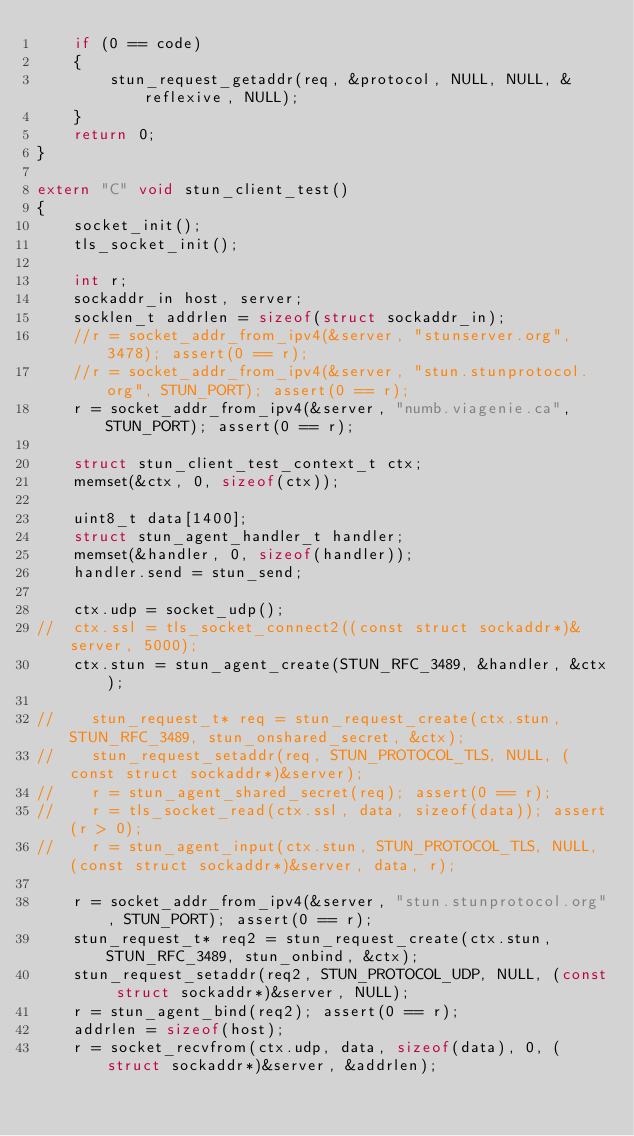Convert code to text. <code><loc_0><loc_0><loc_500><loc_500><_C++_>	if (0 == code)
	{
		stun_request_getaddr(req, &protocol, NULL, NULL, &reflexive, NULL);
	}
	return 0;
}

extern "C" void stun_client_test()
{
	socket_init();
	tls_socket_init();

	int r;
    sockaddr_in host, server;
	socklen_t addrlen = sizeof(struct sockaddr_in);
	//r = socket_addr_from_ipv4(&server, "stunserver.org", 3478); assert(0 == r);
	//r = socket_addr_from_ipv4(&server, "stun.stunprotocol.org", STUN_PORT); assert(0 == r);
	r = socket_addr_from_ipv4(&server, "numb.viagenie.ca", STUN_PORT); assert(0 == r);
    
	struct stun_client_test_context_t ctx;
	memset(&ctx, 0, sizeof(ctx));

	uint8_t data[1400];
	struct stun_agent_handler_t handler;
	memset(&handler, 0, sizeof(handler));
	handler.send = stun_send;

	ctx.udp = socket_udp();
//	ctx.ssl = tls_socket_connect2((const struct sockaddr*)&server, 5000);
	ctx.stun = stun_agent_create(STUN_RFC_3489, &handler, &ctx);

//    stun_request_t* req = stun_request_create(ctx.stun, STUN_RFC_3489, stun_onshared_secret, &ctx);
//    stun_request_setaddr(req, STUN_PROTOCOL_TLS, NULL, (const struct sockaddr*)&server);
//    r = stun_agent_shared_secret(req); assert(0 == r);
//    r = tls_socket_read(ctx.ssl, data, sizeof(data)); assert(r > 0);
//    r = stun_agent_input(ctx.stun, STUN_PROTOCOL_TLS, NULL, (const struct sockaddr*)&server, data, r);

	r = socket_addr_from_ipv4(&server, "stun.stunprotocol.org", STUN_PORT); assert(0 == r);
    stun_request_t* req2 = stun_request_create(ctx.stun, STUN_RFC_3489, stun_onbind, &ctx);
	stun_request_setaddr(req2, STUN_PROTOCOL_UDP, NULL, (const struct sockaddr*)&server, NULL);
	r = stun_agent_bind(req2); assert(0 == r);
    addrlen = sizeof(host);
	r = socket_recvfrom(ctx.udp, data, sizeof(data), 0, (struct sockaddr*)&server, &addrlen);</code> 